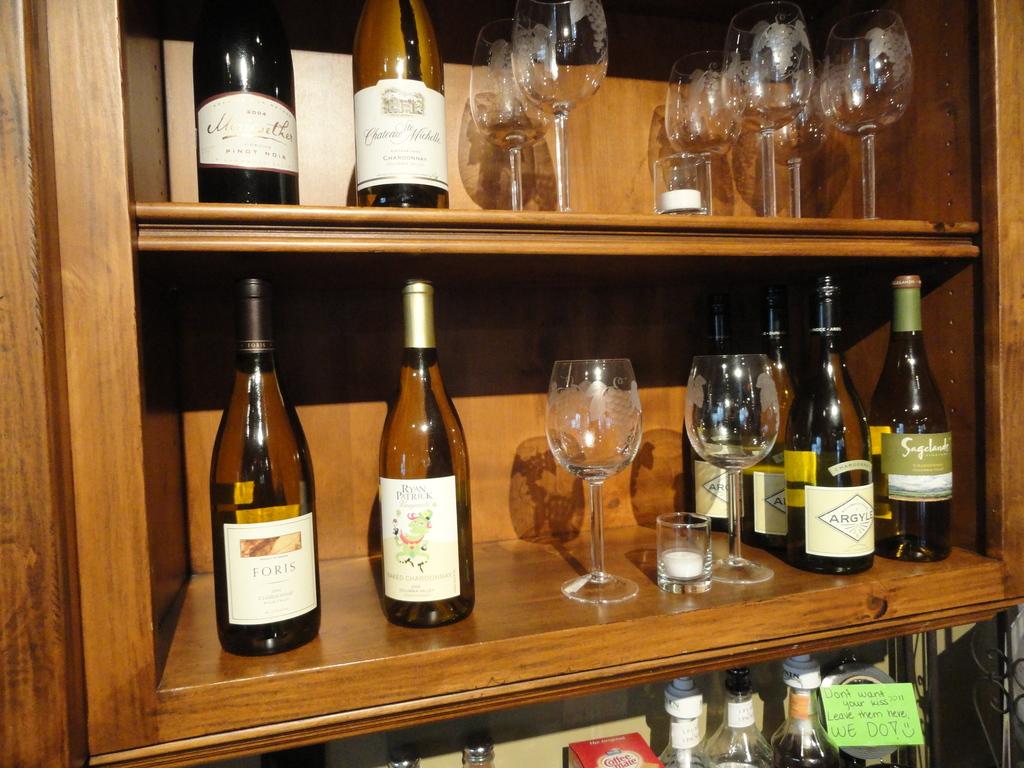What does the green note on the bottom say?
Offer a very short reply. Don't want your kiss??!! leave them here, we do!. 